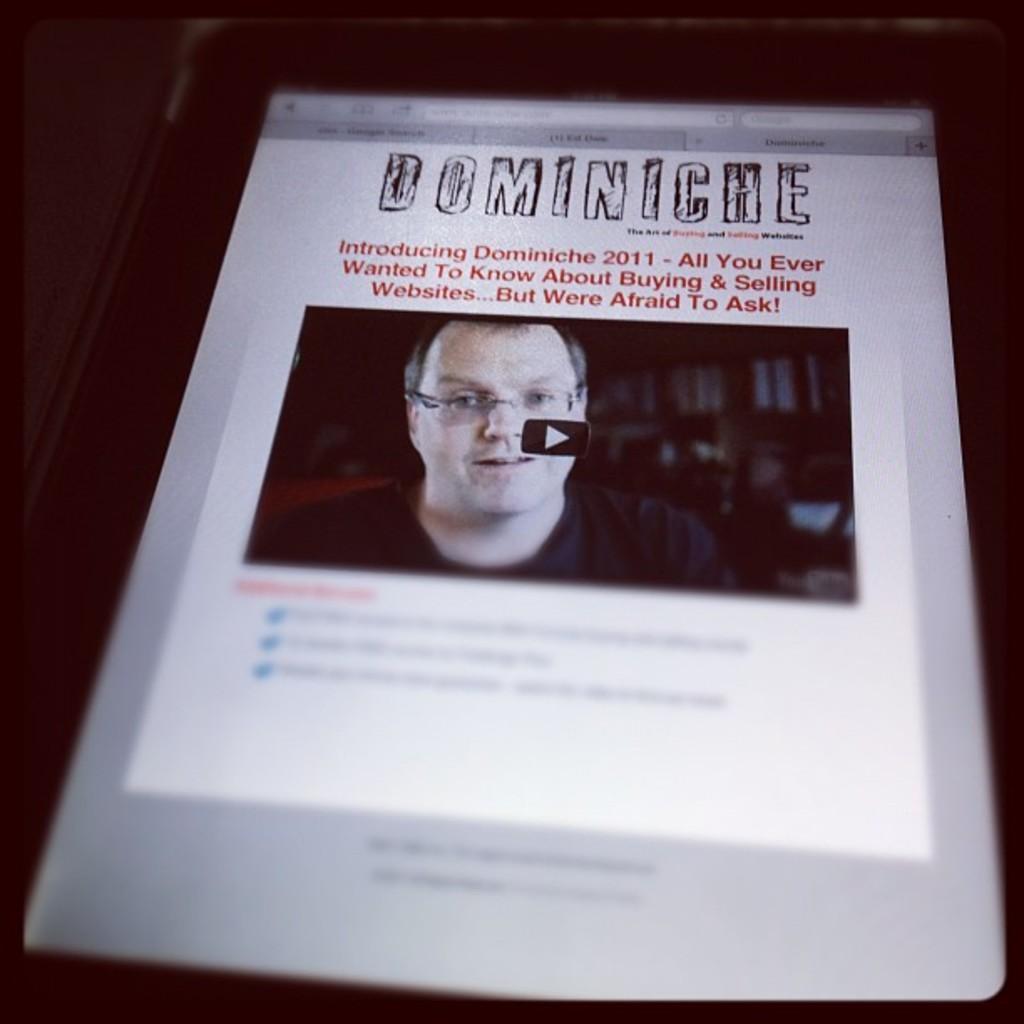Could you give a brief overview of what you see in this image? In this image I can see the person face and something on the screen. It looks like an electronic device. Background is in black color. 